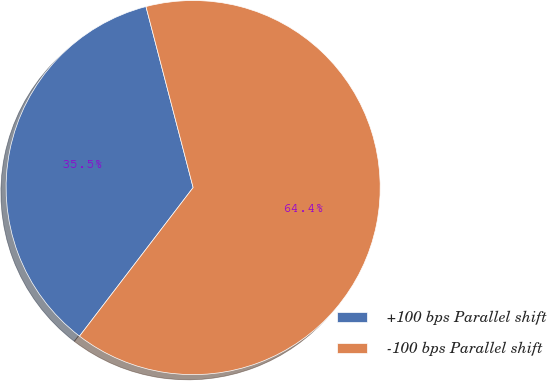<chart> <loc_0><loc_0><loc_500><loc_500><pie_chart><fcel>+100 bps Parallel shift<fcel>-100 bps Parallel shift<nl><fcel>35.55%<fcel>64.45%<nl></chart> 